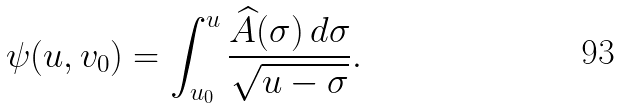Convert formula to latex. <formula><loc_0><loc_0><loc_500><loc_500>\psi ( u , v _ { 0 } ) = \int _ { u _ { 0 } } ^ { u } \frac { \widehat { A } ( \sigma ) \, d \sigma } { \sqrt { u - \sigma } } .</formula> 